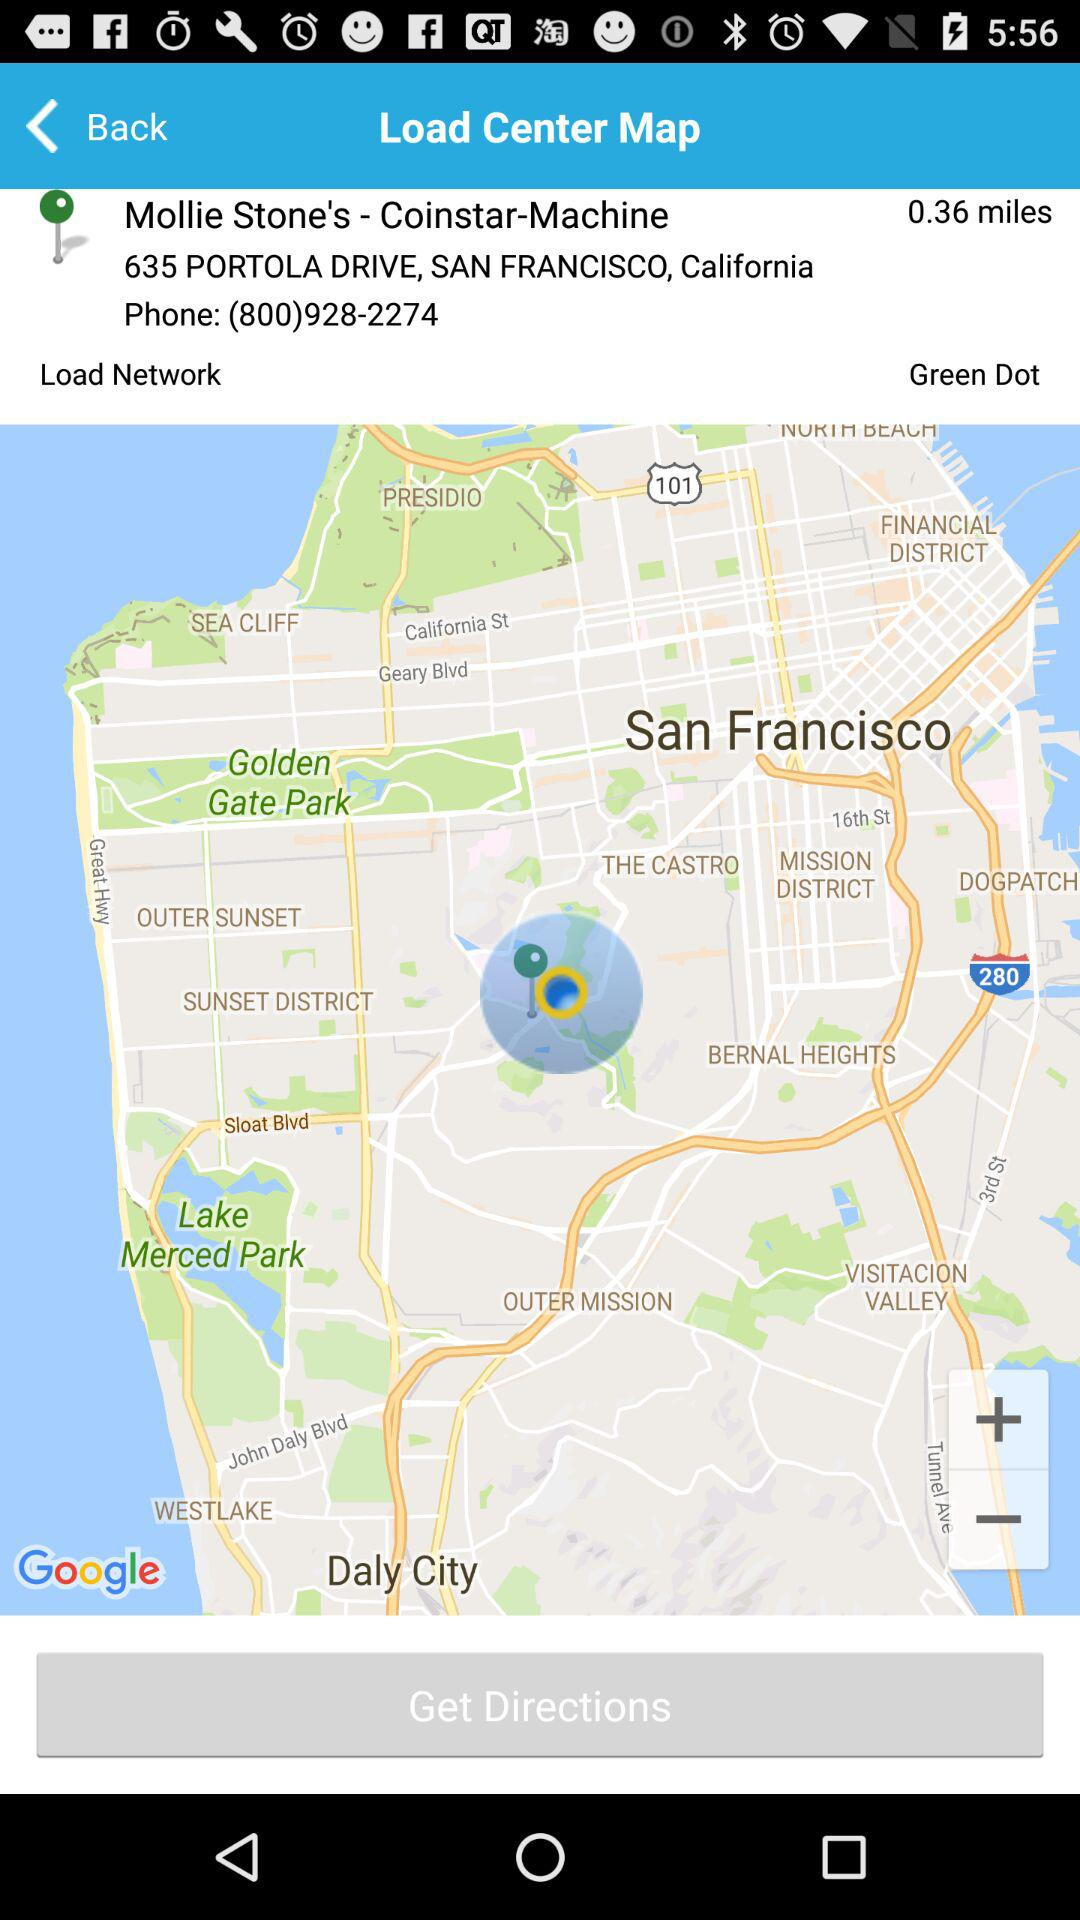How many miles away is the location?
Answer the question using a single word or phrase. 0.36 